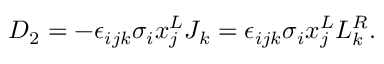Convert formula to latex. <formula><loc_0><loc_0><loc_500><loc_500>D _ { 2 } = - \epsilon _ { i j k } \sigma _ { i } x _ { j } ^ { L } J _ { k } = \epsilon _ { i j k } \sigma _ { i } x _ { j } ^ { L } L _ { k } ^ { R } .</formula> 